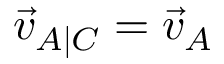<formula> <loc_0><loc_0><loc_500><loc_500>{ \vec { v } } _ { A | C } = { \vec { v } } _ { A }</formula> 